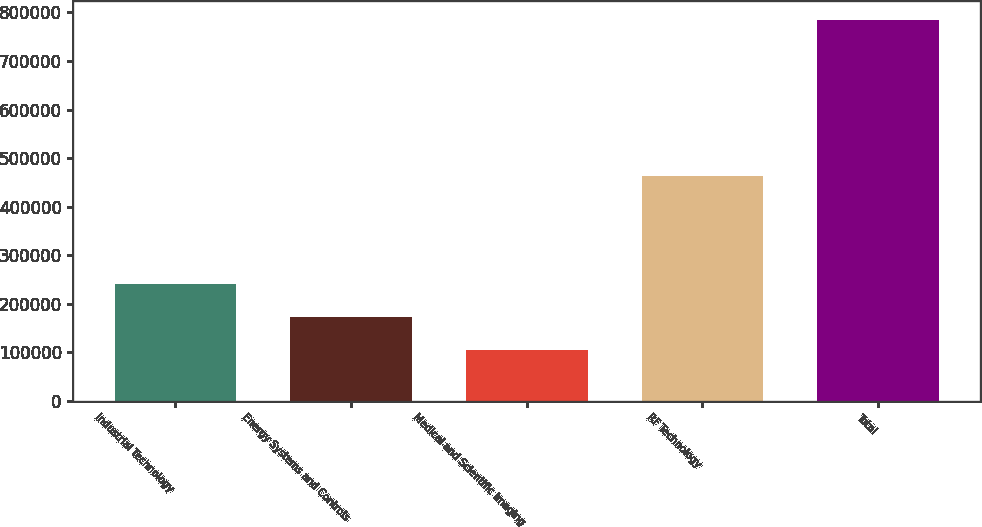<chart> <loc_0><loc_0><loc_500><loc_500><bar_chart><fcel>Industrial Technology<fcel>Energy Systems and Controls<fcel>Medical and Scientific Imaging<fcel>RF Technology<fcel>Total<nl><fcel>240108<fcel>171952<fcel>103796<fcel>463115<fcel>785358<nl></chart> 